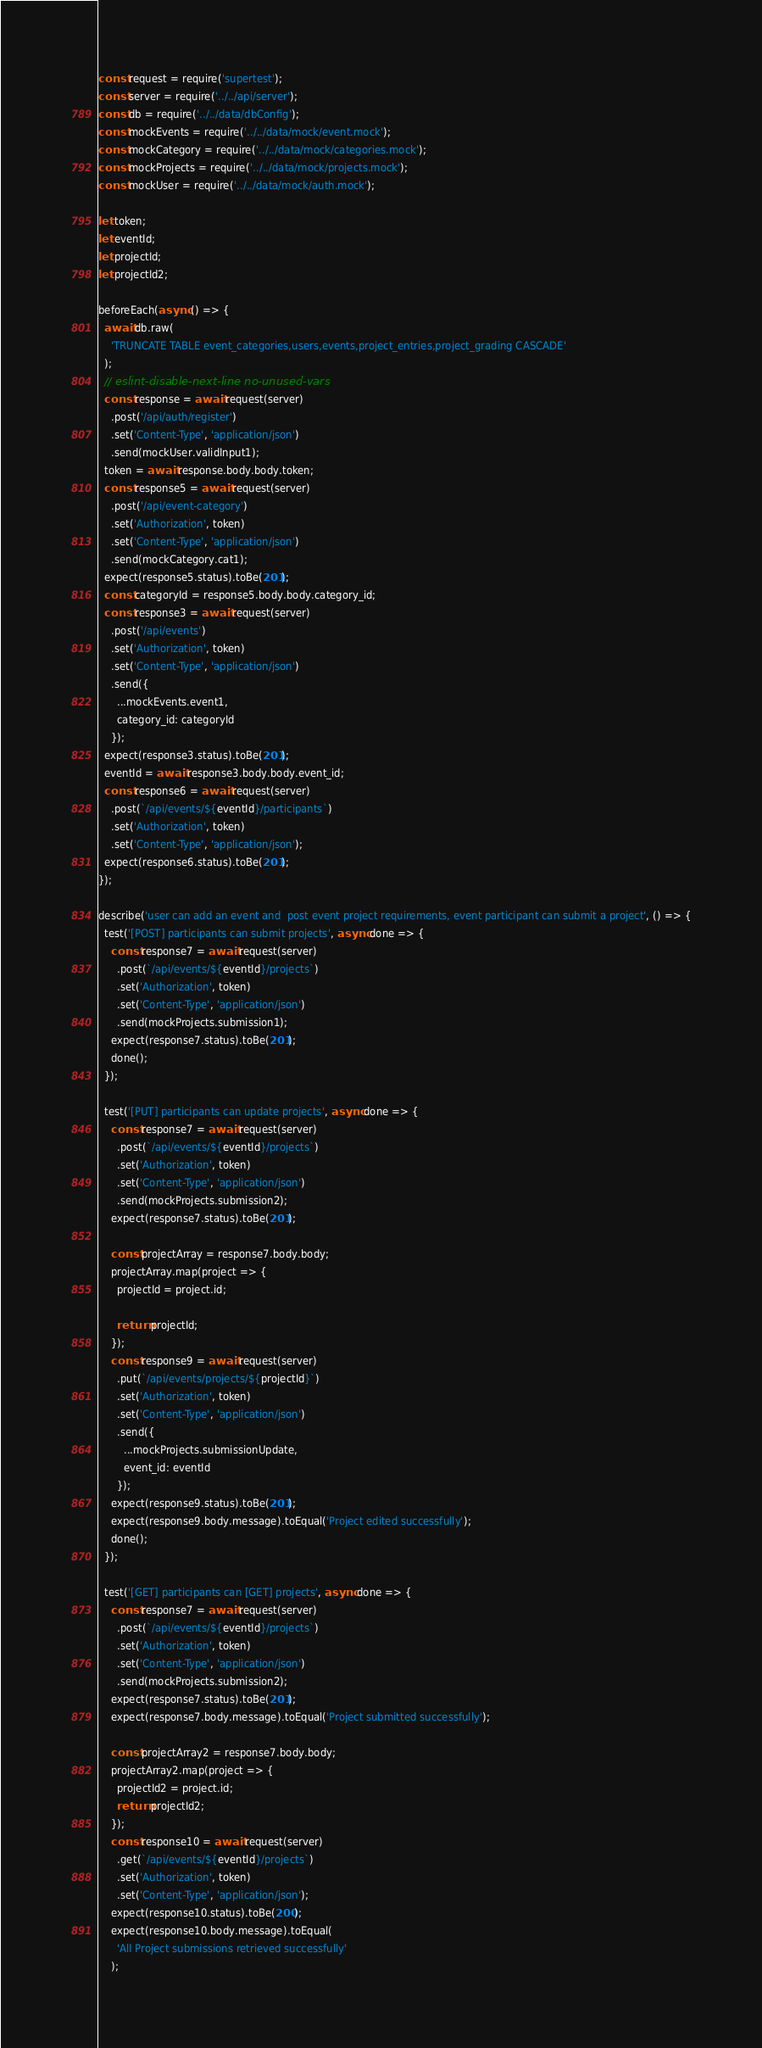Convert code to text. <code><loc_0><loc_0><loc_500><loc_500><_JavaScript_>const request = require('supertest');
const server = require('../../api/server');
const db = require('../../data/dbConfig');
const mockEvents = require('../../data/mock/event.mock');
const mockCategory = require('../../data/mock/categories.mock');
const mockProjects = require('../../data/mock/projects.mock');
const mockUser = require('../../data/mock/auth.mock');

let token;
let eventId;
let projectId;
let projectId2;

beforeEach(async () => {
  await db.raw(
    'TRUNCATE TABLE event_categories,users,events,project_entries,project_grading CASCADE'
  );
  // eslint-disable-next-line no-unused-vars
  const response = await request(server)
    .post('/api/auth/register')
    .set('Content-Type', 'application/json')
    .send(mockUser.validInput1);
  token = await response.body.body.token;
  const response5 = await request(server)
    .post('/api/event-category')
    .set('Authorization', token)
    .set('Content-Type', 'application/json')
    .send(mockCategory.cat1);
  expect(response5.status).toBe(201);
  const categoryId = response5.body.body.category_id;
  const response3 = await request(server)
    .post('/api/events')
    .set('Authorization', token)
    .set('Content-Type', 'application/json')
    .send({
      ...mockEvents.event1,
      category_id: categoryId
    });
  expect(response3.status).toBe(201);
  eventId = await response3.body.body.event_id;
  const response6 = await request(server)
    .post(`/api/events/${eventId}/participants`)
    .set('Authorization', token)
    .set('Content-Type', 'application/json');
  expect(response6.status).toBe(201);
});

describe('user can add an event and  post event project requirements, event participant can submit a project', () => {
  test('[POST] participants can submit projects', async done => {
    const response7 = await request(server)
      .post(`/api/events/${eventId}/projects`)
      .set('Authorization', token)
      .set('Content-Type', 'application/json')
      .send(mockProjects.submission1);
    expect(response7.status).toBe(201);
    done();
  });

  test('[PUT] participants can update projects', async done => {
    const response7 = await request(server)
      .post(`/api/events/${eventId}/projects`)
      .set('Authorization', token)
      .set('Content-Type', 'application/json')
      .send(mockProjects.submission2);
    expect(response7.status).toBe(201);

    const projectArray = response7.body.body;
    projectArray.map(project => {
      projectId = project.id;

      return projectId;
    });
    const response9 = await request(server)
      .put(`/api/events/projects/${projectId}`)
      .set('Authorization', token)
      .set('Content-Type', 'application/json')
      .send({
        ...mockProjects.submissionUpdate,
        event_id: eventId
      });
    expect(response9.status).toBe(201);
    expect(response9.body.message).toEqual('Project edited successfully');
    done();
  });

  test('[GET] participants can [GET] projects', async done => {
    const response7 = await request(server)
      .post(`/api/events/${eventId}/projects`)
      .set('Authorization', token)
      .set('Content-Type', 'application/json')
      .send(mockProjects.submission2);
    expect(response7.status).toBe(201);
    expect(response7.body.message).toEqual('Project submitted successfully');

    const projectArray2 = response7.body.body;
    projectArray2.map(project => {
      projectId2 = project.id;
      return projectId2;
    });
    const response10 = await request(server)
      .get(`/api/events/${eventId}/projects`)
      .set('Authorization', token)
      .set('Content-Type', 'application/json');
    expect(response10.status).toBe(200);
    expect(response10.body.message).toEqual(
      'All Project submissions retrieved successfully'
    );</code> 